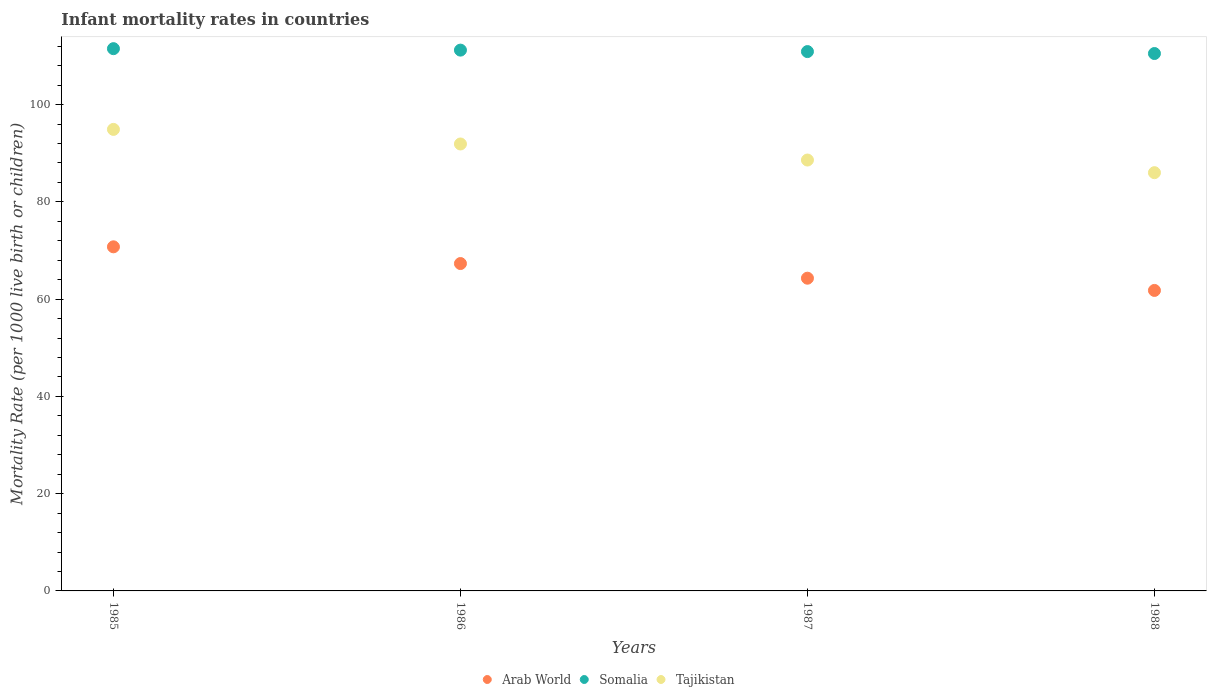What is the infant mortality rate in Arab World in 1988?
Ensure brevity in your answer.  61.79. Across all years, what is the maximum infant mortality rate in Arab World?
Your answer should be compact. 70.75. Across all years, what is the minimum infant mortality rate in Arab World?
Ensure brevity in your answer.  61.79. What is the total infant mortality rate in Arab World in the graph?
Your response must be concise. 264.16. What is the difference between the infant mortality rate in Somalia in 1985 and that in 1986?
Offer a very short reply. 0.3. What is the difference between the infant mortality rate in Arab World in 1988 and the infant mortality rate in Tajikistan in 1987?
Keep it short and to the point. -26.81. What is the average infant mortality rate in Tajikistan per year?
Ensure brevity in your answer.  90.35. In the year 1985, what is the difference between the infant mortality rate in Arab World and infant mortality rate in Tajikistan?
Give a very brief answer. -24.15. What is the ratio of the infant mortality rate in Somalia in 1987 to that in 1988?
Your response must be concise. 1. Is the infant mortality rate in Arab World in 1987 less than that in 1988?
Offer a very short reply. No. Is the difference between the infant mortality rate in Arab World in 1985 and 1986 greater than the difference between the infant mortality rate in Tajikistan in 1985 and 1986?
Give a very brief answer. Yes. What is the difference between the highest and the second highest infant mortality rate in Arab World?
Provide a short and direct response. 3.44. What is the difference between the highest and the lowest infant mortality rate in Somalia?
Offer a very short reply. 1. Is it the case that in every year, the sum of the infant mortality rate in Tajikistan and infant mortality rate in Somalia  is greater than the infant mortality rate in Arab World?
Provide a short and direct response. Yes. How many years are there in the graph?
Ensure brevity in your answer.  4. Are the values on the major ticks of Y-axis written in scientific E-notation?
Ensure brevity in your answer.  No. Does the graph contain any zero values?
Offer a terse response. No. How many legend labels are there?
Offer a very short reply. 3. What is the title of the graph?
Provide a succinct answer. Infant mortality rates in countries. What is the label or title of the Y-axis?
Give a very brief answer. Mortality Rate (per 1000 live birth or children). What is the Mortality Rate (per 1000 live birth or children) in Arab World in 1985?
Make the answer very short. 70.75. What is the Mortality Rate (per 1000 live birth or children) in Somalia in 1985?
Your answer should be very brief. 111.5. What is the Mortality Rate (per 1000 live birth or children) in Tajikistan in 1985?
Your answer should be compact. 94.9. What is the Mortality Rate (per 1000 live birth or children) of Arab World in 1986?
Make the answer very short. 67.32. What is the Mortality Rate (per 1000 live birth or children) of Somalia in 1986?
Your response must be concise. 111.2. What is the Mortality Rate (per 1000 live birth or children) in Tajikistan in 1986?
Give a very brief answer. 91.9. What is the Mortality Rate (per 1000 live birth or children) in Arab World in 1987?
Your answer should be very brief. 64.3. What is the Mortality Rate (per 1000 live birth or children) of Somalia in 1987?
Make the answer very short. 110.9. What is the Mortality Rate (per 1000 live birth or children) in Tajikistan in 1987?
Your answer should be very brief. 88.6. What is the Mortality Rate (per 1000 live birth or children) of Arab World in 1988?
Your response must be concise. 61.79. What is the Mortality Rate (per 1000 live birth or children) in Somalia in 1988?
Offer a terse response. 110.5. What is the Mortality Rate (per 1000 live birth or children) in Tajikistan in 1988?
Provide a succinct answer. 86. Across all years, what is the maximum Mortality Rate (per 1000 live birth or children) in Arab World?
Your answer should be very brief. 70.75. Across all years, what is the maximum Mortality Rate (per 1000 live birth or children) of Somalia?
Make the answer very short. 111.5. Across all years, what is the maximum Mortality Rate (per 1000 live birth or children) in Tajikistan?
Your response must be concise. 94.9. Across all years, what is the minimum Mortality Rate (per 1000 live birth or children) of Arab World?
Offer a terse response. 61.79. Across all years, what is the minimum Mortality Rate (per 1000 live birth or children) of Somalia?
Keep it short and to the point. 110.5. Across all years, what is the minimum Mortality Rate (per 1000 live birth or children) in Tajikistan?
Give a very brief answer. 86. What is the total Mortality Rate (per 1000 live birth or children) of Arab World in the graph?
Your answer should be very brief. 264.16. What is the total Mortality Rate (per 1000 live birth or children) of Somalia in the graph?
Offer a terse response. 444.1. What is the total Mortality Rate (per 1000 live birth or children) in Tajikistan in the graph?
Your response must be concise. 361.4. What is the difference between the Mortality Rate (per 1000 live birth or children) in Arab World in 1985 and that in 1986?
Provide a short and direct response. 3.44. What is the difference between the Mortality Rate (per 1000 live birth or children) in Somalia in 1985 and that in 1986?
Provide a short and direct response. 0.3. What is the difference between the Mortality Rate (per 1000 live birth or children) of Arab World in 1985 and that in 1987?
Your response must be concise. 6.45. What is the difference between the Mortality Rate (per 1000 live birth or children) in Somalia in 1985 and that in 1987?
Offer a very short reply. 0.6. What is the difference between the Mortality Rate (per 1000 live birth or children) in Tajikistan in 1985 and that in 1987?
Provide a succinct answer. 6.3. What is the difference between the Mortality Rate (per 1000 live birth or children) in Arab World in 1985 and that in 1988?
Offer a terse response. 8.97. What is the difference between the Mortality Rate (per 1000 live birth or children) of Somalia in 1985 and that in 1988?
Your response must be concise. 1. What is the difference between the Mortality Rate (per 1000 live birth or children) of Arab World in 1986 and that in 1987?
Keep it short and to the point. 3.01. What is the difference between the Mortality Rate (per 1000 live birth or children) of Somalia in 1986 and that in 1987?
Your answer should be compact. 0.3. What is the difference between the Mortality Rate (per 1000 live birth or children) in Tajikistan in 1986 and that in 1987?
Your answer should be very brief. 3.3. What is the difference between the Mortality Rate (per 1000 live birth or children) in Arab World in 1986 and that in 1988?
Offer a very short reply. 5.53. What is the difference between the Mortality Rate (per 1000 live birth or children) of Somalia in 1986 and that in 1988?
Offer a very short reply. 0.7. What is the difference between the Mortality Rate (per 1000 live birth or children) in Tajikistan in 1986 and that in 1988?
Provide a short and direct response. 5.9. What is the difference between the Mortality Rate (per 1000 live birth or children) in Arab World in 1987 and that in 1988?
Keep it short and to the point. 2.52. What is the difference between the Mortality Rate (per 1000 live birth or children) of Somalia in 1987 and that in 1988?
Ensure brevity in your answer.  0.4. What is the difference between the Mortality Rate (per 1000 live birth or children) of Tajikistan in 1987 and that in 1988?
Provide a short and direct response. 2.6. What is the difference between the Mortality Rate (per 1000 live birth or children) of Arab World in 1985 and the Mortality Rate (per 1000 live birth or children) of Somalia in 1986?
Ensure brevity in your answer.  -40.45. What is the difference between the Mortality Rate (per 1000 live birth or children) in Arab World in 1985 and the Mortality Rate (per 1000 live birth or children) in Tajikistan in 1986?
Offer a terse response. -21.15. What is the difference between the Mortality Rate (per 1000 live birth or children) of Somalia in 1985 and the Mortality Rate (per 1000 live birth or children) of Tajikistan in 1986?
Your response must be concise. 19.6. What is the difference between the Mortality Rate (per 1000 live birth or children) of Arab World in 1985 and the Mortality Rate (per 1000 live birth or children) of Somalia in 1987?
Ensure brevity in your answer.  -40.15. What is the difference between the Mortality Rate (per 1000 live birth or children) in Arab World in 1985 and the Mortality Rate (per 1000 live birth or children) in Tajikistan in 1987?
Provide a succinct answer. -17.85. What is the difference between the Mortality Rate (per 1000 live birth or children) in Somalia in 1985 and the Mortality Rate (per 1000 live birth or children) in Tajikistan in 1987?
Offer a terse response. 22.9. What is the difference between the Mortality Rate (per 1000 live birth or children) in Arab World in 1985 and the Mortality Rate (per 1000 live birth or children) in Somalia in 1988?
Make the answer very short. -39.75. What is the difference between the Mortality Rate (per 1000 live birth or children) of Arab World in 1985 and the Mortality Rate (per 1000 live birth or children) of Tajikistan in 1988?
Make the answer very short. -15.25. What is the difference between the Mortality Rate (per 1000 live birth or children) in Arab World in 1986 and the Mortality Rate (per 1000 live birth or children) in Somalia in 1987?
Offer a terse response. -43.58. What is the difference between the Mortality Rate (per 1000 live birth or children) of Arab World in 1986 and the Mortality Rate (per 1000 live birth or children) of Tajikistan in 1987?
Offer a terse response. -21.28. What is the difference between the Mortality Rate (per 1000 live birth or children) of Somalia in 1986 and the Mortality Rate (per 1000 live birth or children) of Tajikistan in 1987?
Ensure brevity in your answer.  22.6. What is the difference between the Mortality Rate (per 1000 live birth or children) of Arab World in 1986 and the Mortality Rate (per 1000 live birth or children) of Somalia in 1988?
Ensure brevity in your answer.  -43.18. What is the difference between the Mortality Rate (per 1000 live birth or children) of Arab World in 1986 and the Mortality Rate (per 1000 live birth or children) of Tajikistan in 1988?
Make the answer very short. -18.68. What is the difference between the Mortality Rate (per 1000 live birth or children) of Somalia in 1986 and the Mortality Rate (per 1000 live birth or children) of Tajikistan in 1988?
Your answer should be compact. 25.2. What is the difference between the Mortality Rate (per 1000 live birth or children) of Arab World in 1987 and the Mortality Rate (per 1000 live birth or children) of Somalia in 1988?
Provide a short and direct response. -46.2. What is the difference between the Mortality Rate (per 1000 live birth or children) in Arab World in 1987 and the Mortality Rate (per 1000 live birth or children) in Tajikistan in 1988?
Give a very brief answer. -21.7. What is the difference between the Mortality Rate (per 1000 live birth or children) in Somalia in 1987 and the Mortality Rate (per 1000 live birth or children) in Tajikistan in 1988?
Provide a short and direct response. 24.9. What is the average Mortality Rate (per 1000 live birth or children) of Arab World per year?
Give a very brief answer. 66.04. What is the average Mortality Rate (per 1000 live birth or children) in Somalia per year?
Give a very brief answer. 111.03. What is the average Mortality Rate (per 1000 live birth or children) of Tajikistan per year?
Ensure brevity in your answer.  90.35. In the year 1985, what is the difference between the Mortality Rate (per 1000 live birth or children) of Arab World and Mortality Rate (per 1000 live birth or children) of Somalia?
Your answer should be very brief. -40.75. In the year 1985, what is the difference between the Mortality Rate (per 1000 live birth or children) in Arab World and Mortality Rate (per 1000 live birth or children) in Tajikistan?
Your response must be concise. -24.15. In the year 1986, what is the difference between the Mortality Rate (per 1000 live birth or children) in Arab World and Mortality Rate (per 1000 live birth or children) in Somalia?
Provide a succinct answer. -43.88. In the year 1986, what is the difference between the Mortality Rate (per 1000 live birth or children) of Arab World and Mortality Rate (per 1000 live birth or children) of Tajikistan?
Keep it short and to the point. -24.58. In the year 1986, what is the difference between the Mortality Rate (per 1000 live birth or children) of Somalia and Mortality Rate (per 1000 live birth or children) of Tajikistan?
Your response must be concise. 19.3. In the year 1987, what is the difference between the Mortality Rate (per 1000 live birth or children) in Arab World and Mortality Rate (per 1000 live birth or children) in Somalia?
Give a very brief answer. -46.6. In the year 1987, what is the difference between the Mortality Rate (per 1000 live birth or children) in Arab World and Mortality Rate (per 1000 live birth or children) in Tajikistan?
Give a very brief answer. -24.3. In the year 1987, what is the difference between the Mortality Rate (per 1000 live birth or children) of Somalia and Mortality Rate (per 1000 live birth or children) of Tajikistan?
Provide a short and direct response. 22.3. In the year 1988, what is the difference between the Mortality Rate (per 1000 live birth or children) in Arab World and Mortality Rate (per 1000 live birth or children) in Somalia?
Your answer should be compact. -48.71. In the year 1988, what is the difference between the Mortality Rate (per 1000 live birth or children) of Arab World and Mortality Rate (per 1000 live birth or children) of Tajikistan?
Provide a succinct answer. -24.21. What is the ratio of the Mortality Rate (per 1000 live birth or children) of Arab World in 1985 to that in 1986?
Provide a short and direct response. 1.05. What is the ratio of the Mortality Rate (per 1000 live birth or children) of Somalia in 1985 to that in 1986?
Your answer should be very brief. 1. What is the ratio of the Mortality Rate (per 1000 live birth or children) in Tajikistan in 1985 to that in 1986?
Offer a very short reply. 1.03. What is the ratio of the Mortality Rate (per 1000 live birth or children) of Arab World in 1985 to that in 1987?
Provide a short and direct response. 1.1. What is the ratio of the Mortality Rate (per 1000 live birth or children) of Somalia in 1985 to that in 1987?
Provide a short and direct response. 1.01. What is the ratio of the Mortality Rate (per 1000 live birth or children) of Tajikistan in 1985 to that in 1987?
Your answer should be very brief. 1.07. What is the ratio of the Mortality Rate (per 1000 live birth or children) of Arab World in 1985 to that in 1988?
Provide a succinct answer. 1.15. What is the ratio of the Mortality Rate (per 1000 live birth or children) in Somalia in 1985 to that in 1988?
Keep it short and to the point. 1.01. What is the ratio of the Mortality Rate (per 1000 live birth or children) in Tajikistan in 1985 to that in 1988?
Ensure brevity in your answer.  1.1. What is the ratio of the Mortality Rate (per 1000 live birth or children) in Arab World in 1986 to that in 1987?
Keep it short and to the point. 1.05. What is the ratio of the Mortality Rate (per 1000 live birth or children) of Tajikistan in 1986 to that in 1987?
Give a very brief answer. 1.04. What is the ratio of the Mortality Rate (per 1000 live birth or children) of Arab World in 1986 to that in 1988?
Keep it short and to the point. 1.09. What is the ratio of the Mortality Rate (per 1000 live birth or children) of Somalia in 1986 to that in 1988?
Your response must be concise. 1.01. What is the ratio of the Mortality Rate (per 1000 live birth or children) of Tajikistan in 1986 to that in 1988?
Your response must be concise. 1.07. What is the ratio of the Mortality Rate (per 1000 live birth or children) in Arab World in 1987 to that in 1988?
Ensure brevity in your answer.  1.04. What is the ratio of the Mortality Rate (per 1000 live birth or children) in Tajikistan in 1987 to that in 1988?
Make the answer very short. 1.03. What is the difference between the highest and the second highest Mortality Rate (per 1000 live birth or children) of Arab World?
Provide a succinct answer. 3.44. What is the difference between the highest and the second highest Mortality Rate (per 1000 live birth or children) in Tajikistan?
Your response must be concise. 3. What is the difference between the highest and the lowest Mortality Rate (per 1000 live birth or children) of Arab World?
Your response must be concise. 8.97. What is the difference between the highest and the lowest Mortality Rate (per 1000 live birth or children) of Somalia?
Your answer should be compact. 1. 